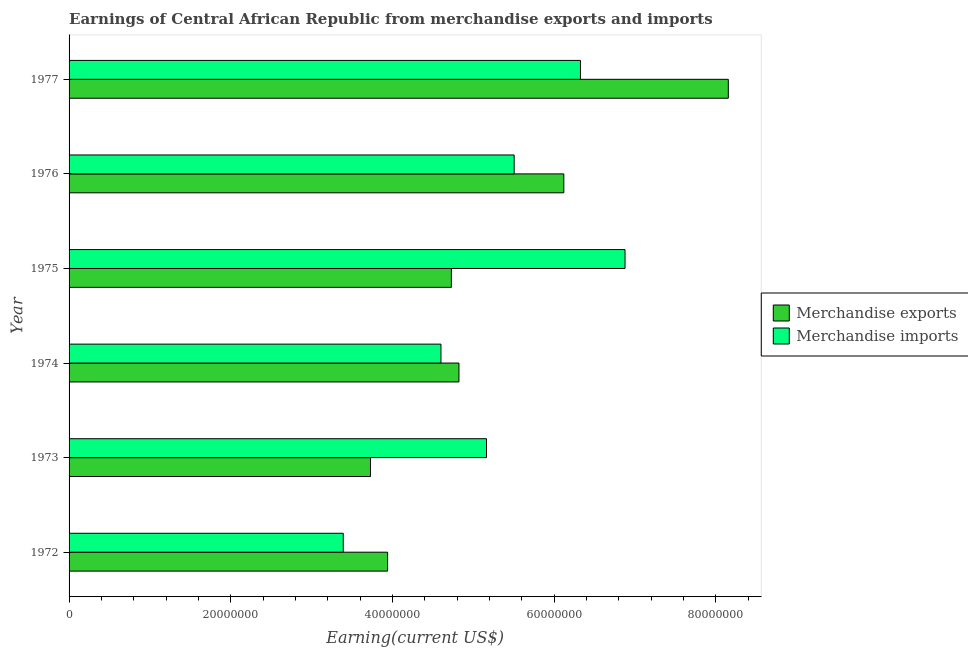How many groups of bars are there?
Offer a very short reply. 6. Are the number of bars per tick equal to the number of legend labels?
Give a very brief answer. Yes. Are the number of bars on each tick of the Y-axis equal?
Provide a short and direct response. Yes. How many bars are there on the 1st tick from the top?
Provide a succinct answer. 2. How many bars are there on the 1st tick from the bottom?
Give a very brief answer. 2. What is the label of the 5th group of bars from the top?
Your answer should be compact. 1973. What is the earnings from merchandise imports in 1977?
Your response must be concise. 6.33e+07. Across all years, what is the maximum earnings from merchandise exports?
Your answer should be very brief. 8.15e+07. Across all years, what is the minimum earnings from merchandise exports?
Make the answer very short. 3.73e+07. In which year was the earnings from merchandise exports maximum?
Offer a terse response. 1977. What is the total earnings from merchandise exports in the graph?
Your answer should be very brief. 3.15e+08. What is the difference between the earnings from merchandise imports in 1974 and that in 1977?
Offer a very short reply. -1.73e+07. What is the difference between the earnings from merchandise exports in 1975 and the earnings from merchandise imports in 1977?
Keep it short and to the point. -1.60e+07. What is the average earnings from merchandise exports per year?
Make the answer very short. 5.25e+07. In the year 1975, what is the difference between the earnings from merchandise imports and earnings from merchandise exports?
Offer a very short reply. 2.15e+07. Is the earnings from merchandise imports in 1974 less than that in 1977?
Your answer should be compact. Yes. Is the difference between the earnings from merchandise imports in 1975 and 1977 greater than the difference between the earnings from merchandise exports in 1975 and 1977?
Offer a very short reply. Yes. What is the difference between the highest and the second highest earnings from merchandise exports?
Your answer should be very brief. 2.03e+07. What is the difference between the highest and the lowest earnings from merchandise imports?
Provide a short and direct response. 3.49e+07. How many bars are there?
Ensure brevity in your answer.  12. Are all the bars in the graph horizontal?
Your answer should be very brief. Yes. How many years are there in the graph?
Ensure brevity in your answer.  6. Where does the legend appear in the graph?
Make the answer very short. Center right. How many legend labels are there?
Keep it short and to the point. 2. How are the legend labels stacked?
Ensure brevity in your answer.  Vertical. What is the title of the graph?
Provide a succinct answer. Earnings of Central African Republic from merchandise exports and imports. Does "Foreign liabilities" appear as one of the legend labels in the graph?
Offer a very short reply. No. What is the label or title of the X-axis?
Your answer should be compact. Earning(current US$). What is the label or title of the Y-axis?
Give a very brief answer. Year. What is the Earning(current US$) in Merchandise exports in 1972?
Keep it short and to the point. 3.94e+07. What is the Earning(current US$) in Merchandise imports in 1972?
Offer a terse response. 3.39e+07. What is the Earning(current US$) of Merchandise exports in 1973?
Offer a terse response. 3.73e+07. What is the Earning(current US$) in Merchandise imports in 1973?
Offer a very short reply. 5.16e+07. What is the Earning(current US$) in Merchandise exports in 1974?
Make the answer very short. 4.82e+07. What is the Earning(current US$) in Merchandise imports in 1974?
Make the answer very short. 4.60e+07. What is the Earning(current US$) of Merchandise exports in 1975?
Give a very brief answer. 4.73e+07. What is the Earning(current US$) in Merchandise imports in 1975?
Give a very brief answer. 6.88e+07. What is the Earning(current US$) in Merchandise exports in 1976?
Keep it short and to the point. 6.12e+07. What is the Earning(current US$) in Merchandise imports in 1976?
Offer a terse response. 5.51e+07. What is the Earning(current US$) of Merchandise exports in 1977?
Keep it short and to the point. 8.15e+07. What is the Earning(current US$) of Merchandise imports in 1977?
Offer a very short reply. 6.33e+07. Across all years, what is the maximum Earning(current US$) of Merchandise exports?
Ensure brevity in your answer.  8.15e+07. Across all years, what is the maximum Earning(current US$) in Merchandise imports?
Your response must be concise. 6.88e+07. Across all years, what is the minimum Earning(current US$) in Merchandise exports?
Your answer should be very brief. 3.73e+07. Across all years, what is the minimum Earning(current US$) in Merchandise imports?
Provide a short and direct response. 3.39e+07. What is the total Earning(current US$) of Merchandise exports in the graph?
Ensure brevity in your answer.  3.15e+08. What is the total Earning(current US$) in Merchandise imports in the graph?
Your answer should be very brief. 3.19e+08. What is the difference between the Earning(current US$) of Merchandise exports in 1972 and that in 1973?
Keep it short and to the point. 2.12e+06. What is the difference between the Earning(current US$) in Merchandise imports in 1972 and that in 1973?
Ensure brevity in your answer.  -1.77e+07. What is the difference between the Earning(current US$) in Merchandise exports in 1972 and that in 1974?
Ensure brevity in your answer.  -8.82e+06. What is the difference between the Earning(current US$) in Merchandise imports in 1972 and that in 1974?
Ensure brevity in your answer.  -1.21e+07. What is the difference between the Earning(current US$) of Merchandise exports in 1972 and that in 1975?
Ensure brevity in your answer.  -7.89e+06. What is the difference between the Earning(current US$) of Merchandise imports in 1972 and that in 1975?
Give a very brief answer. -3.49e+07. What is the difference between the Earning(current US$) of Merchandise exports in 1972 and that in 1976?
Provide a succinct answer. -2.18e+07. What is the difference between the Earning(current US$) in Merchandise imports in 1972 and that in 1976?
Your response must be concise. -2.11e+07. What is the difference between the Earning(current US$) of Merchandise exports in 1972 and that in 1977?
Offer a very short reply. -4.21e+07. What is the difference between the Earning(current US$) in Merchandise imports in 1972 and that in 1977?
Your answer should be compact. -2.93e+07. What is the difference between the Earning(current US$) in Merchandise exports in 1973 and that in 1974?
Provide a succinct answer. -1.09e+07. What is the difference between the Earning(current US$) in Merchandise imports in 1973 and that in 1974?
Provide a short and direct response. 5.64e+06. What is the difference between the Earning(current US$) in Merchandise exports in 1973 and that in 1975?
Provide a short and direct response. -1.00e+07. What is the difference between the Earning(current US$) in Merchandise imports in 1973 and that in 1975?
Your answer should be compact. -1.71e+07. What is the difference between the Earning(current US$) in Merchandise exports in 1973 and that in 1976?
Offer a very short reply. -2.39e+07. What is the difference between the Earning(current US$) in Merchandise imports in 1973 and that in 1976?
Keep it short and to the point. -3.42e+06. What is the difference between the Earning(current US$) of Merchandise exports in 1973 and that in 1977?
Make the answer very short. -4.43e+07. What is the difference between the Earning(current US$) of Merchandise imports in 1973 and that in 1977?
Provide a short and direct response. -1.16e+07. What is the difference between the Earning(current US$) of Merchandise exports in 1974 and that in 1975?
Your answer should be very brief. 9.37e+05. What is the difference between the Earning(current US$) of Merchandise imports in 1974 and that in 1975?
Your answer should be very brief. -2.28e+07. What is the difference between the Earning(current US$) of Merchandise exports in 1974 and that in 1976?
Provide a short and direct response. -1.30e+07. What is the difference between the Earning(current US$) in Merchandise imports in 1974 and that in 1976?
Ensure brevity in your answer.  -9.06e+06. What is the difference between the Earning(current US$) of Merchandise exports in 1974 and that in 1977?
Make the answer very short. -3.33e+07. What is the difference between the Earning(current US$) of Merchandise imports in 1974 and that in 1977?
Your answer should be compact. -1.73e+07. What is the difference between the Earning(current US$) in Merchandise exports in 1975 and that in 1976?
Make the answer very short. -1.39e+07. What is the difference between the Earning(current US$) in Merchandise imports in 1975 and that in 1976?
Make the answer very short. 1.37e+07. What is the difference between the Earning(current US$) in Merchandise exports in 1975 and that in 1977?
Ensure brevity in your answer.  -3.43e+07. What is the difference between the Earning(current US$) in Merchandise imports in 1975 and that in 1977?
Make the answer very short. 5.51e+06. What is the difference between the Earning(current US$) in Merchandise exports in 1976 and that in 1977?
Ensure brevity in your answer.  -2.03e+07. What is the difference between the Earning(current US$) of Merchandise imports in 1976 and that in 1977?
Your answer should be very brief. -8.20e+06. What is the difference between the Earning(current US$) in Merchandise exports in 1972 and the Earning(current US$) in Merchandise imports in 1973?
Offer a terse response. -1.22e+07. What is the difference between the Earning(current US$) in Merchandise exports in 1972 and the Earning(current US$) in Merchandise imports in 1974?
Ensure brevity in your answer.  -6.60e+06. What is the difference between the Earning(current US$) in Merchandise exports in 1972 and the Earning(current US$) in Merchandise imports in 1975?
Provide a succinct answer. -2.94e+07. What is the difference between the Earning(current US$) in Merchandise exports in 1972 and the Earning(current US$) in Merchandise imports in 1976?
Provide a short and direct response. -1.57e+07. What is the difference between the Earning(current US$) of Merchandise exports in 1972 and the Earning(current US$) of Merchandise imports in 1977?
Offer a terse response. -2.39e+07. What is the difference between the Earning(current US$) of Merchandise exports in 1973 and the Earning(current US$) of Merchandise imports in 1974?
Your answer should be compact. -8.72e+06. What is the difference between the Earning(current US$) in Merchandise exports in 1973 and the Earning(current US$) in Merchandise imports in 1975?
Offer a very short reply. -3.15e+07. What is the difference between the Earning(current US$) in Merchandise exports in 1973 and the Earning(current US$) in Merchandise imports in 1976?
Keep it short and to the point. -1.78e+07. What is the difference between the Earning(current US$) of Merchandise exports in 1973 and the Earning(current US$) of Merchandise imports in 1977?
Provide a succinct answer. -2.60e+07. What is the difference between the Earning(current US$) in Merchandise exports in 1974 and the Earning(current US$) in Merchandise imports in 1975?
Give a very brief answer. -2.05e+07. What is the difference between the Earning(current US$) of Merchandise exports in 1974 and the Earning(current US$) of Merchandise imports in 1976?
Your answer should be very brief. -6.83e+06. What is the difference between the Earning(current US$) in Merchandise exports in 1974 and the Earning(current US$) in Merchandise imports in 1977?
Your response must be concise. -1.50e+07. What is the difference between the Earning(current US$) of Merchandise exports in 1975 and the Earning(current US$) of Merchandise imports in 1976?
Your answer should be compact. -7.77e+06. What is the difference between the Earning(current US$) of Merchandise exports in 1975 and the Earning(current US$) of Merchandise imports in 1977?
Offer a terse response. -1.60e+07. What is the difference between the Earning(current US$) of Merchandise exports in 1976 and the Earning(current US$) of Merchandise imports in 1977?
Give a very brief answer. -2.06e+06. What is the average Earning(current US$) in Merchandise exports per year?
Your answer should be compact. 5.25e+07. What is the average Earning(current US$) of Merchandise imports per year?
Offer a terse response. 5.31e+07. In the year 1972, what is the difference between the Earning(current US$) in Merchandise exports and Earning(current US$) in Merchandise imports?
Your response must be concise. 5.49e+06. In the year 1973, what is the difference between the Earning(current US$) of Merchandise exports and Earning(current US$) of Merchandise imports?
Give a very brief answer. -1.44e+07. In the year 1974, what is the difference between the Earning(current US$) in Merchandise exports and Earning(current US$) in Merchandise imports?
Offer a terse response. 2.23e+06. In the year 1975, what is the difference between the Earning(current US$) in Merchandise exports and Earning(current US$) in Merchandise imports?
Make the answer very short. -2.15e+07. In the year 1976, what is the difference between the Earning(current US$) of Merchandise exports and Earning(current US$) of Merchandise imports?
Make the answer very short. 6.14e+06. In the year 1977, what is the difference between the Earning(current US$) in Merchandise exports and Earning(current US$) in Merchandise imports?
Your response must be concise. 1.83e+07. What is the ratio of the Earning(current US$) of Merchandise exports in 1972 to that in 1973?
Make the answer very short. 1.06. What is the ratio of the Earning(current US$) in Merchandise imports in 1972 to that in 1973?
Your answer should be compact. 0.66. What is the ratio of the Earning(current US$) of Merchandise exports in 1972 to that in 1974?
Provide a short and direct response. 0.82. What is the ratio of the Earning(current US$) in Merchandise imports in 1972 to that in 1974?
Make the answer very short. 0.74. What is the ratio of the Earning(current US$) of Merchandise exports in 1972 to that in 1975?
Give a very brief answer. 0.83. What is the ratio of the Earning(current US$) in Merchandise imports in 1972 to that in 1975?
Make the answer very short. 0.49. What is the ratio of the Earning(current US$) in Merchandise exports in 1972 to that in 1976?
Offer a very short reply. 0.64. What is the ratio of the Earning(current US$) of Merchandise imports in 1972 to that in 1976?
Ensure brevity in your answer.  0.62. What is the ratio of the Earning(current US$) in Merchandise exports in 1972 to that in 1977?
Ensure brevity in your answer.  0.48. What is the ratio of the Earning(current US$) in Merchandise imports in 1972 to that in 1977?
Offer a very short reply. 0.54. What is the ratio of the Earning(current US$) of Merchandise exports in 1973 to that in 1974?
Your answer should be compact. 0.77. What is the ratio of the Earning(current US$) in Merchandise imports in 1973 to that in 1974?
Keep it short and to the point. 1.12. What is the ratio of the Earning(current US$) in Merchandise exports in 1973 to that in 1975?
Your response must be concise. 0.79. What is the ratio of the Earning(current US$) of Merchandise imports in 1973 to that in 1975?
Give a very brief answer. 0.75. What is the ratio of the Earning(current US$) of Merchandise exports in 1973 to that in 1976?
Make the answer very short. 0.61. What is the ratio of the Earning(current US$) of Merchandise imports in 1973 to that in 1976?
Your answer should be compact. 0.94. What is the ratio of the Earning(current US$) in Merchandise exports in 1973 to that in 1977?
Provide a succinct answer. 0.46. What is the ratio of the Earning(current US$) of Merchandise imports in 1973 to that in 1977?
Your answer should be very brief. 0.82. What is the ratio of the Earning(current US$) in Merchandise exports in 1974 to that in 1975?
Ensure brevity in your answer.  1.02. What is the ratio of the Earning(current US$) in Merchandise imports in 1974 to that in 1975?
Keep it short and to the point. 0.67. What is the ratio of the Earning(current US$) of Merchandise exports in 1974 to that in 1976?
Your answer should be compact. 0.79. What is the ratio of the Earning(current US$) in Merchandise imports in 1974 to that in 1976?
Your answer should be very brief. 0.84. What is the ratio of the Earning(current US$) in Merchandise exports in 1974 to that in 1977?
Your answer should be very brief. 0.59. What is the ratio of the Earning(current US$) in Merchandise imports in 1974 to that in 1977?
Offer a very short reply. 0.73. What is the ratio of the Earning(current US$) in Merchandise exports in 1975 to that in 1976?
Offer a terse response. 0.77. What is the ratio of the Earning(current US$) in Merchandise imports in 1975 to that in 1976?
Your answer should be compact. 1.25. What is the ratio of the Earning(current US$) of Merchandise exports in 1975 to that in 1977?
Offer a terse response. 0.58. What is the ratio of the Earning(current US$) in Merchandise imports in 1975 to that in 1977?
Keep it short and to the point. 1.09. What is the ratio of the Earning(current US$) in Merchandise exports in 1976 to that in 1977?
Offer a very short reply. 0.75. What is the ratio of the Earning(current US$) in Merchandise imports in 1976 to that in 1977?
Make the answer very short. 0.87. What is the difference between the highest and the second highest Earning(current US$) in Merchandise exports?
Make the answer very short. 2.03e+07. What is the difference between the highest and the second highest Earning(current US$) in Merchandise imports?
Provide a succinct answer. 5.51e+06. What is the difference between the highest and the lowest Earning(current US$) of Merchandise exports?
Keep it short and to the point. 4.43e+07. What is the difference between the highest and the lowest Earning(current US$) in Merchandise imports?
Your answer should be very brief. 3.49e+07. 